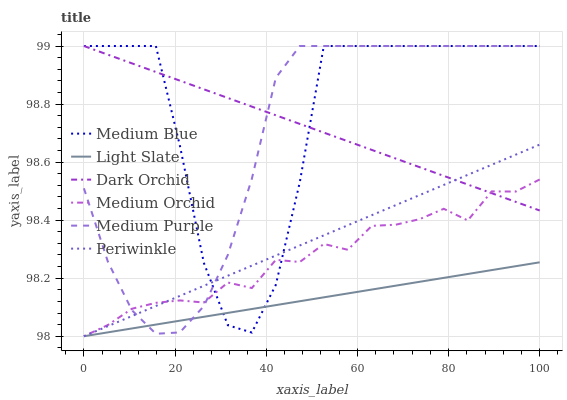Does Light Slate have the minimum area under the curve?
Answer yes or no. Yes. Does Medium Blue have the maximum area under the curve?
Answer yes or no. Yes. Does Medium Orchid have the minimum area under the curve?
Answer yes or no. No. Does Medium Orchid have the maximum area under the curve?
Answer yes or no. No. Is Light Slate the smoothest?
Answer yes or no. Yes. Is Medium Blue the roughest?
Answer yes or no. Yes. Is Medium Orchid the smoothest?
Answer yes or no. No. Is Medium Orchid the roughest?
Answer yes or no. No. Does Light Slate have the lowest value?
Answer yes or no. Yes. Does Medium Blue have the lowest value?
Answer yes or no. No. Does Medium Purple have the highest value?
Answer yes or no. Yes. Does Medium Orchid have the highest value?
Answer yes or no. No. Is Light Slate less than Dark Orchid?
Answer yes or no. Yes. Is Dark Orchid greater than Light Slate?
Answer yes or no. Yes. Does Medium Orchid intersect Medium Blue?
Answer yes or no. Yes. Is Medium Orchid less than Medium Blue?
Answer yes or no. No. Is Medium Orchid greater than Medium Blue?
Answer yes or no. No. Does Light Slate intersect Dark Orchid?
Answer yes or no. No. 